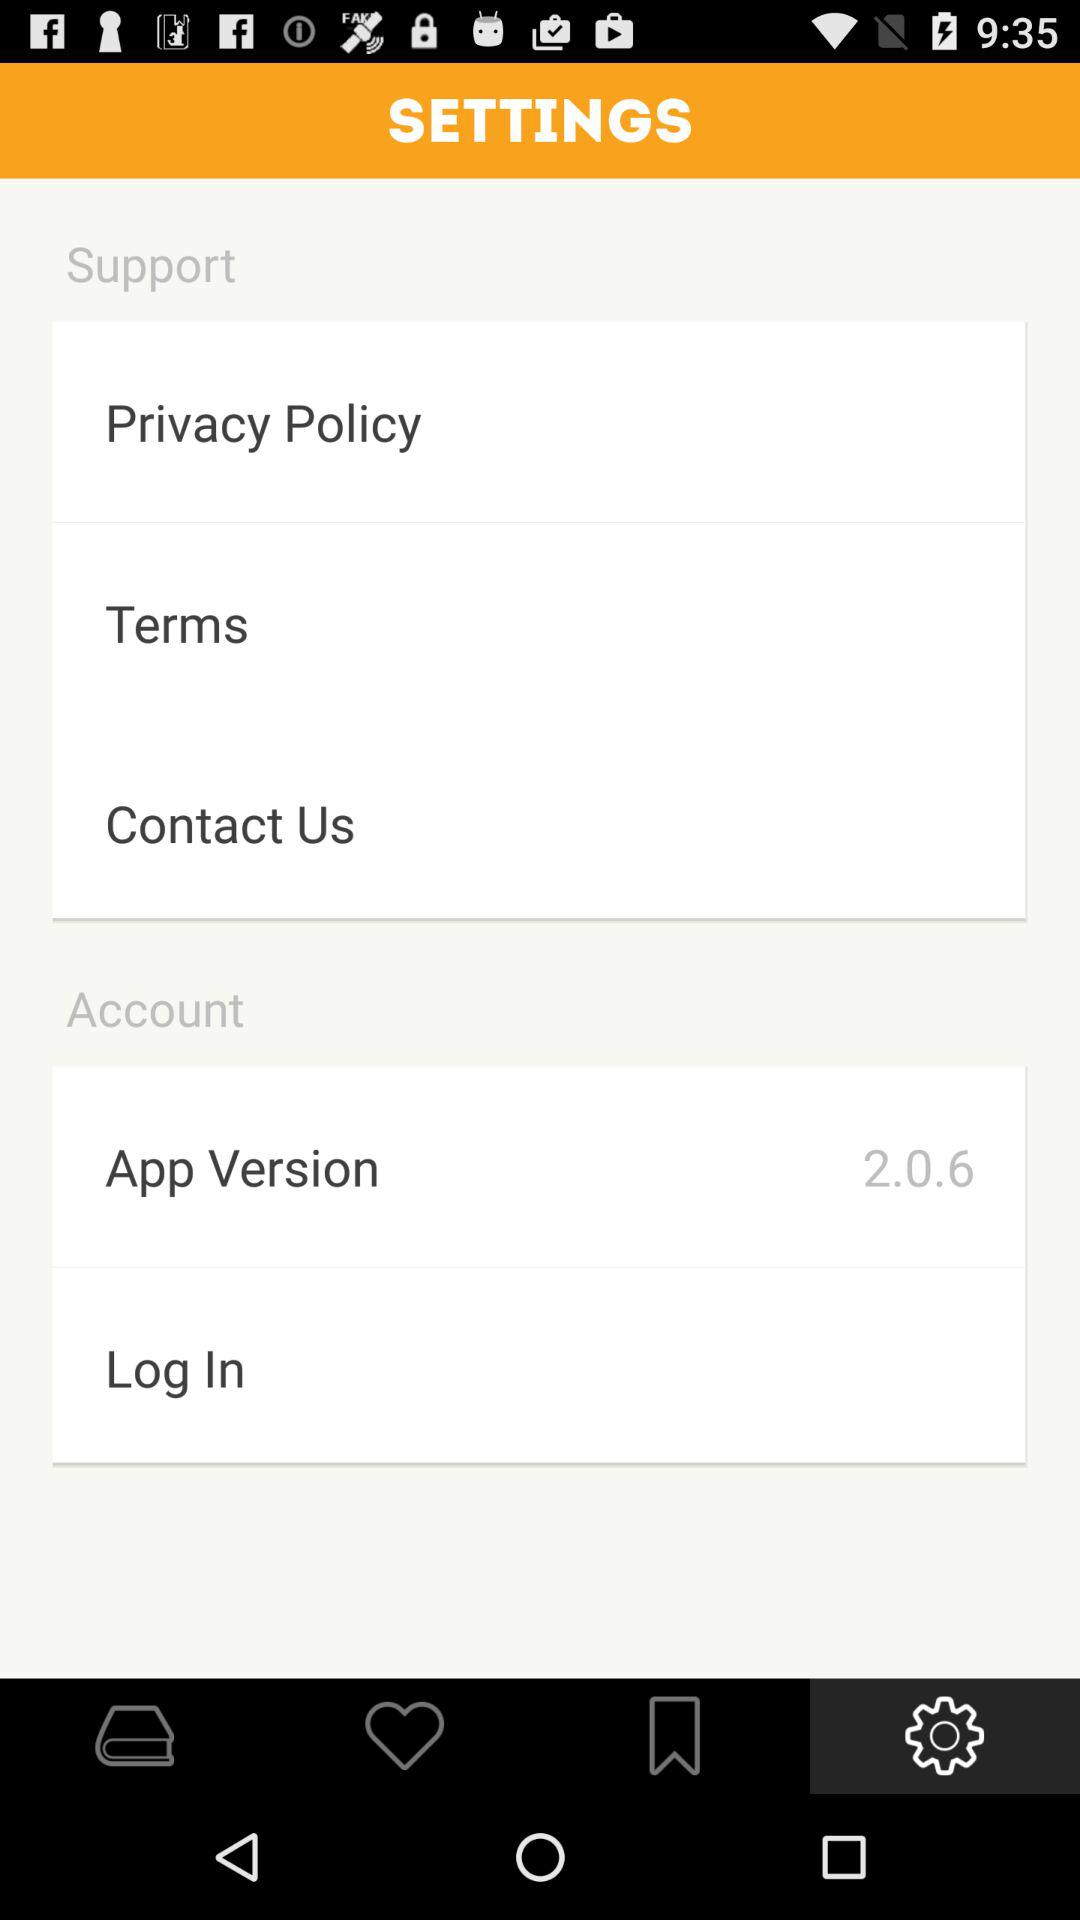Which tab is selected? The selected tab is "Settings". 